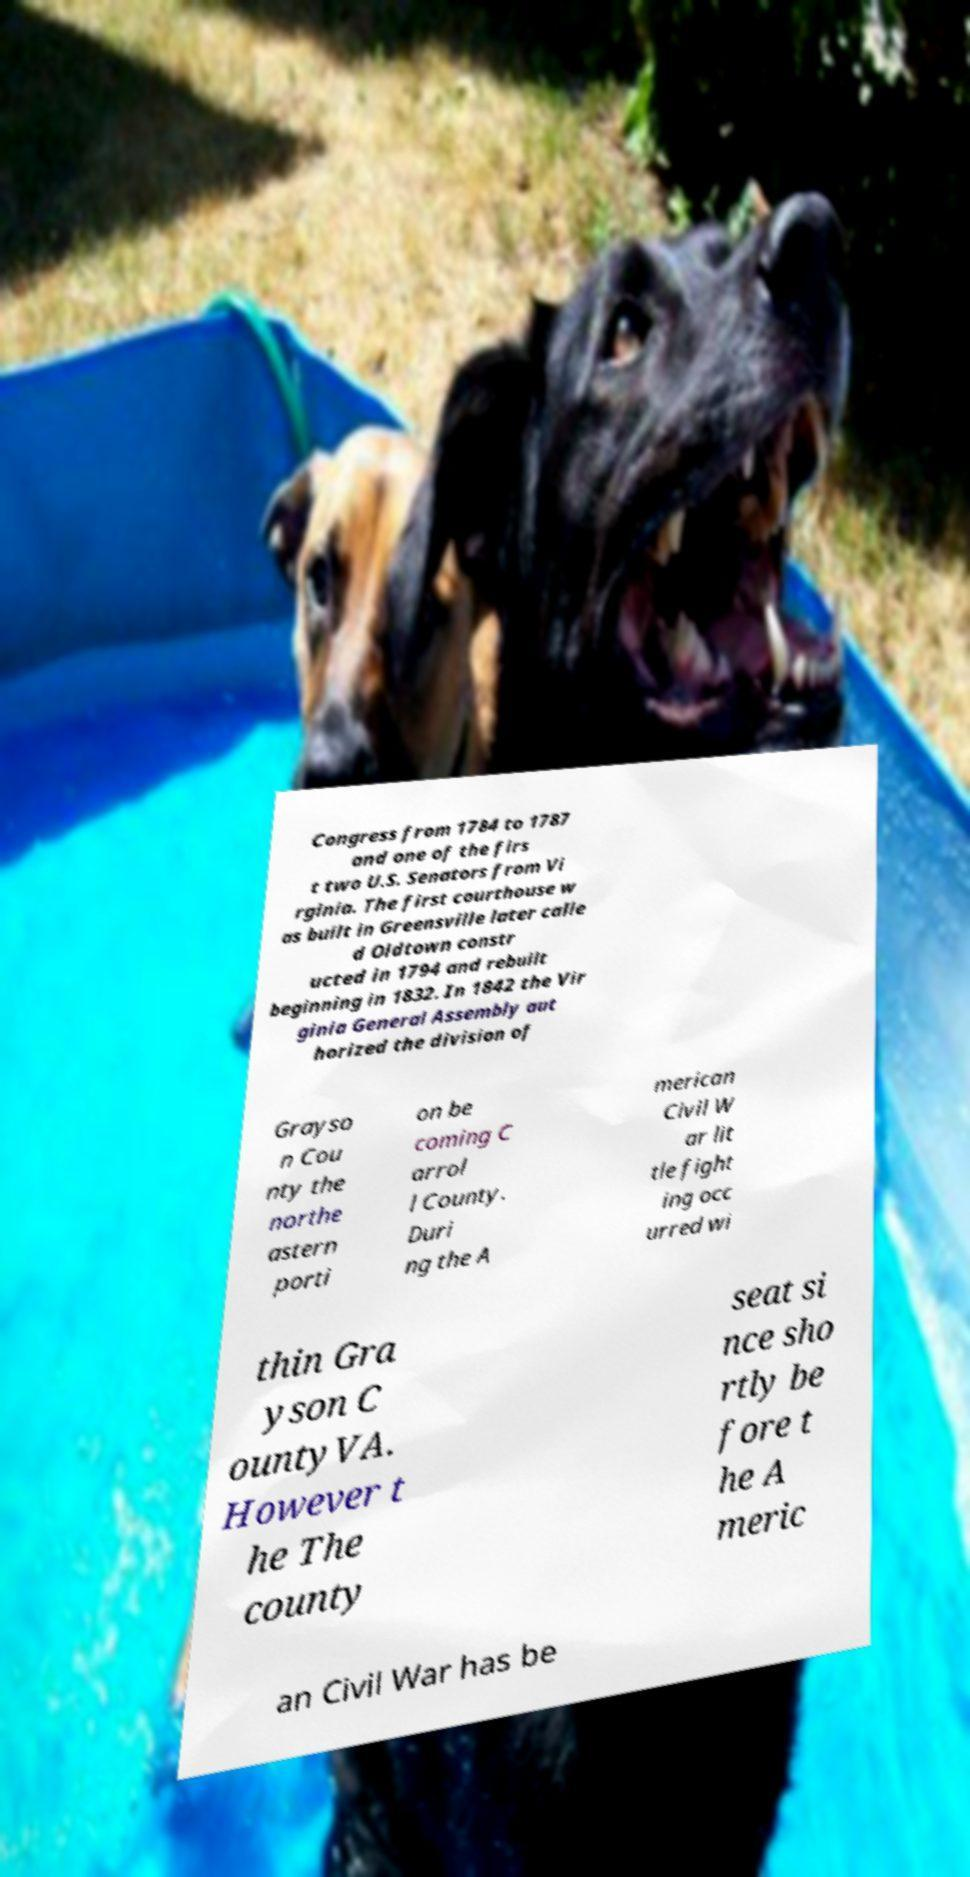Please identify and transcribe the text found in this image. Congress from 1784 to 1787 and one of the firs t two U.S. Senators from Vi rginia. The first courthouse w as built in Greensville later calle d Oldtown constr ucted in 1794 and rebuilt beginning in 1832. In 1842 the Vir ginia General Assembly aut horized the division of Grayso n Cou nty the northe astern porti on be coming C arrol l County. Duri ng the A merican Civil W ar lit tle fight ing occ urred wi thin Gra yson C ountyVA. However t he The county seat si nce sho rtly be fore t he A meric an Civil War has be 